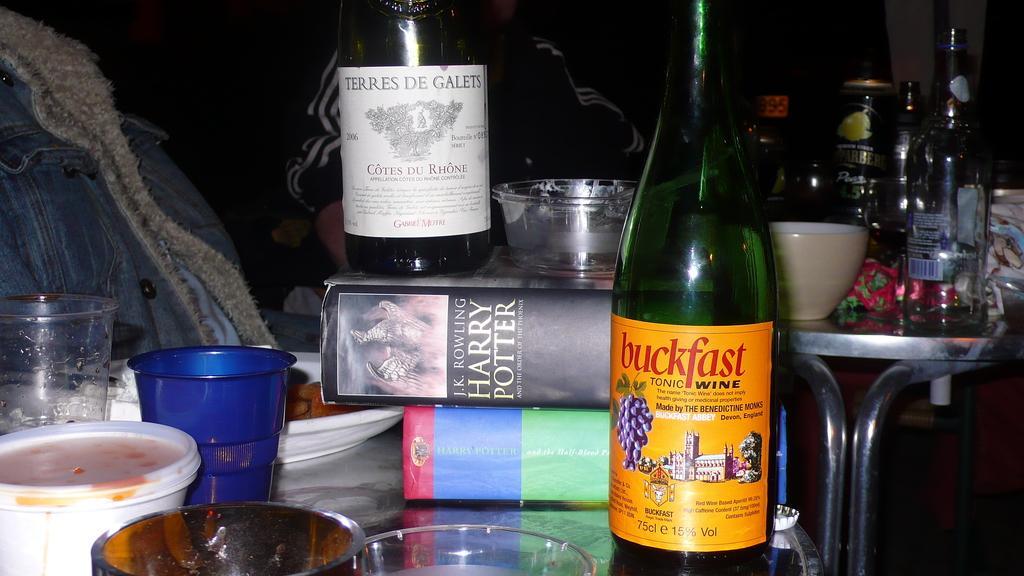Please provide a concise description of this image. This Image consists of bottles, boxes, cups, bucks, plate, bowls, tables and people. All these items are on tables. People are sitting, that in that table. 